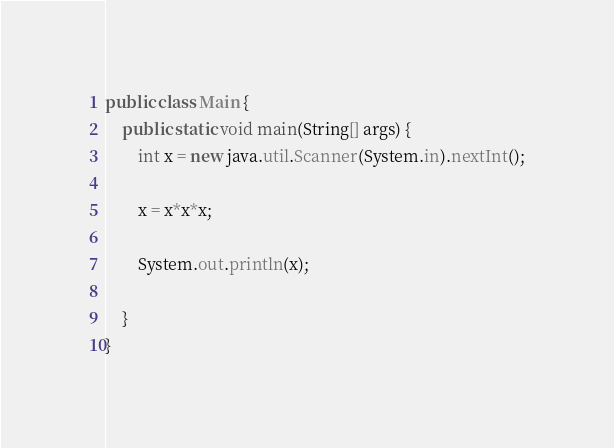<code> <loc_0><loc_0><loc_500><loc_500><_Java_>public class Main {
	public static void main(String[] args) {
		int x = new java.util.Scanner(System.in).nextInt();
		
		x = x*x*x;
		
		System.out.println(x);
		
	}
}</code> 